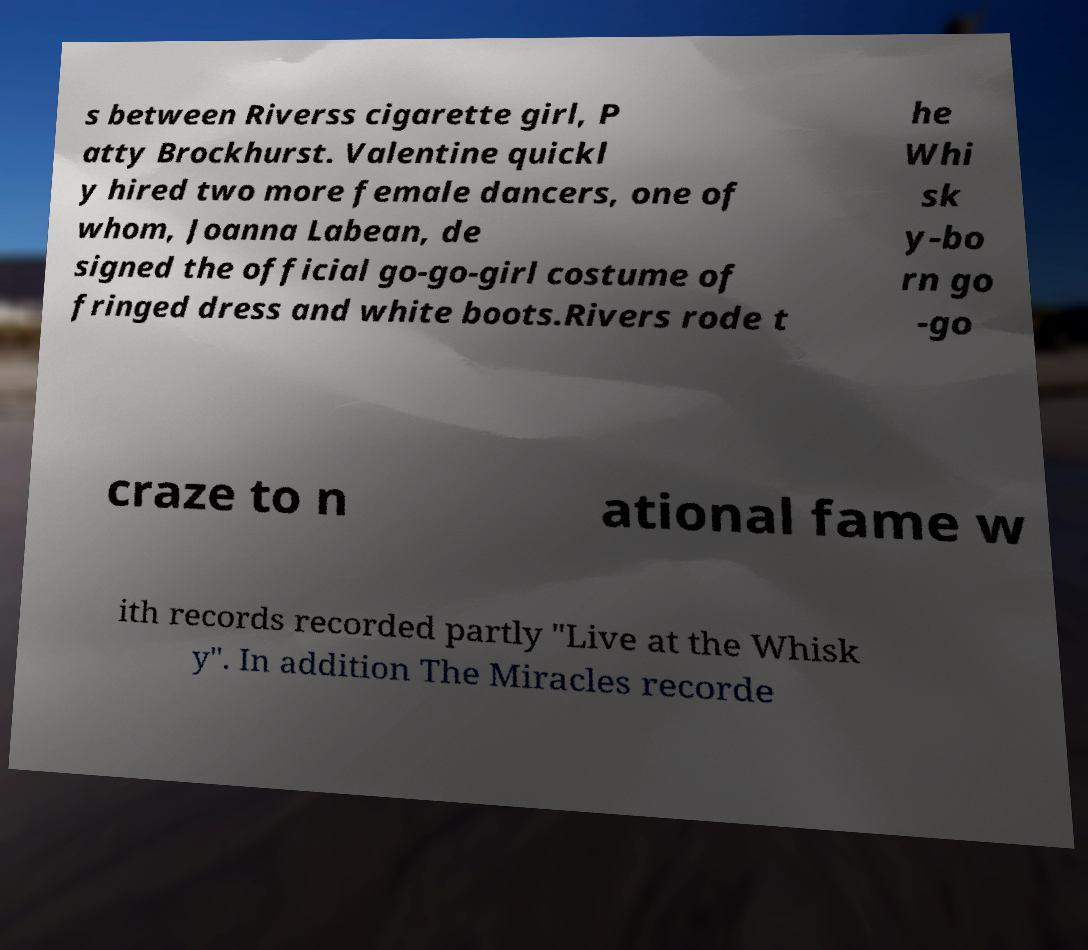For documentation purposes, I need the text within this image transcribed. Could you provide that? s between Riverss cigarette girl, P atty Brockhurst. Valentine quickl y hired two more female dancers, one of whom, Joanna Labean, de signed the official go-go-girl costume of fringed dress and white boots.Rivers rode t he Whi sk y-bo rn go -go craze to n ational fame w ith records recorded partly "Live at the Whisk y". In addition The Miracles recorde 